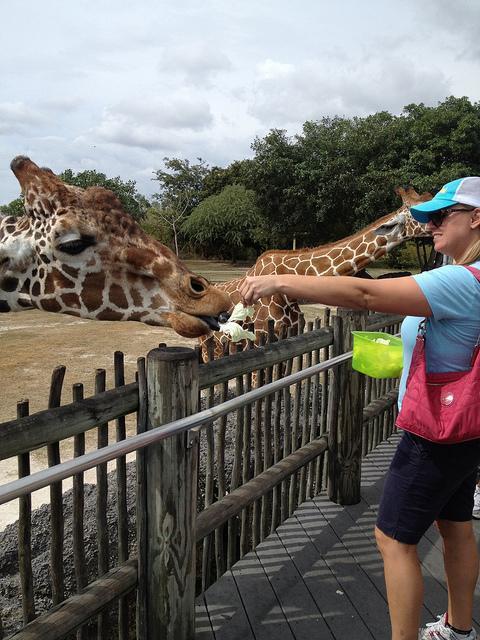How many animals?
Give a very brief answer. 2. How many giraffes are there?
Give a very brief answer. 2. How many dogs are sleeping?
Give a very brief answer. 0. 